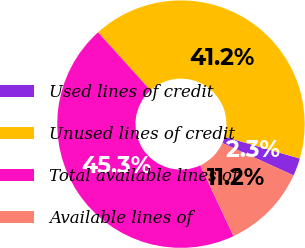<chart> <loc_0><loc_0><loc_500><loc_500><pie_chart><fcel>Used lines of credit<fcel>Unused lines of credit<fcel>Total available lines of<fcel>Available lines of<nl><fcel>2.32%<fcel>41.18%<fcel>45.3%<fcel>11.21%<nl></chart> 